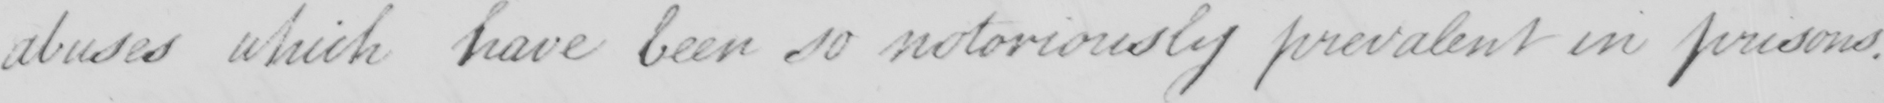What is written in this line of handwriting? abuses which have been so notoriously prevalent in prisons . 